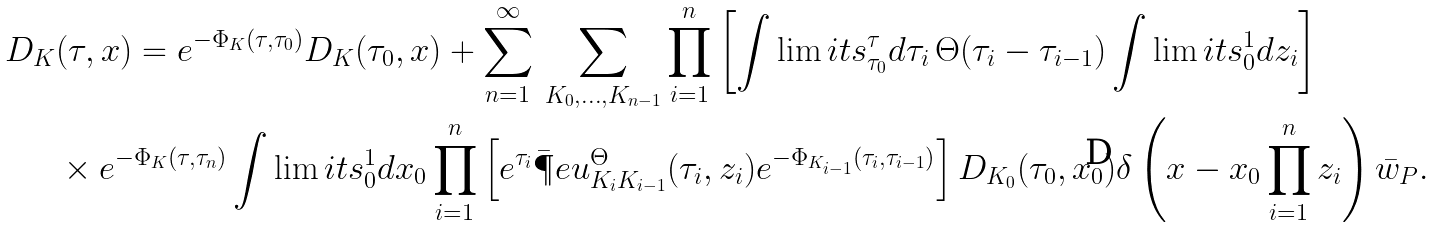Convert formula to latex. <formula><loc_0><loc_0><loc_500><loc_500>D _ { K } & ( \tau , x ) = e ^ { - \Phi _ { K } ( \tau , \tau _ { 0 } ) } D _ { K } ( \tau _ { 0 } , x ) + \sum _ { n = 1 } ^ { \infty } \, \sum _ { K _ { 0 } , \dots , K _ { n - 1 } } \prod _ { i = 1 } ^ { n } \left [ \int \lim i t s _ { \tau _ { 0 } } ^ { \tau } d \tau _ { i } \, \Theta ( \tau _ { i } - \tau _ { i - 1 } ) \int \lim i t s _ { 0 } ^ { 1 } d z _ { i } \right ] \\ & \times e ^ { - \Phi _ { K } ( \tau , \tau _ { n } ) } \int \lim i t s _ { 0 } ^ { 1 } d x _ { 0 } \prod _ { i = 1 } ^ { n } \left [ e ^ { \tau _ { i } } \bar { \P } e u _ { K _ { i } K _ { i - 1 } } ^ { \Theta } ( \tau _ { i } , z _ { i } ) e ^ { - \Phi _ { K _ { i - 1 } } ( \tau _ { i } , \tau _ { i - 1 } ) } \right ] D _ { K _ { 0 } } ( \tau _ { 0 } , x _ { 0 } ) \delta \left ( x - x _ { 0 } \prod _ { i = 1 } ^ { n } z _ { i } \right ) \bar { w } _ { P } .</formula> 